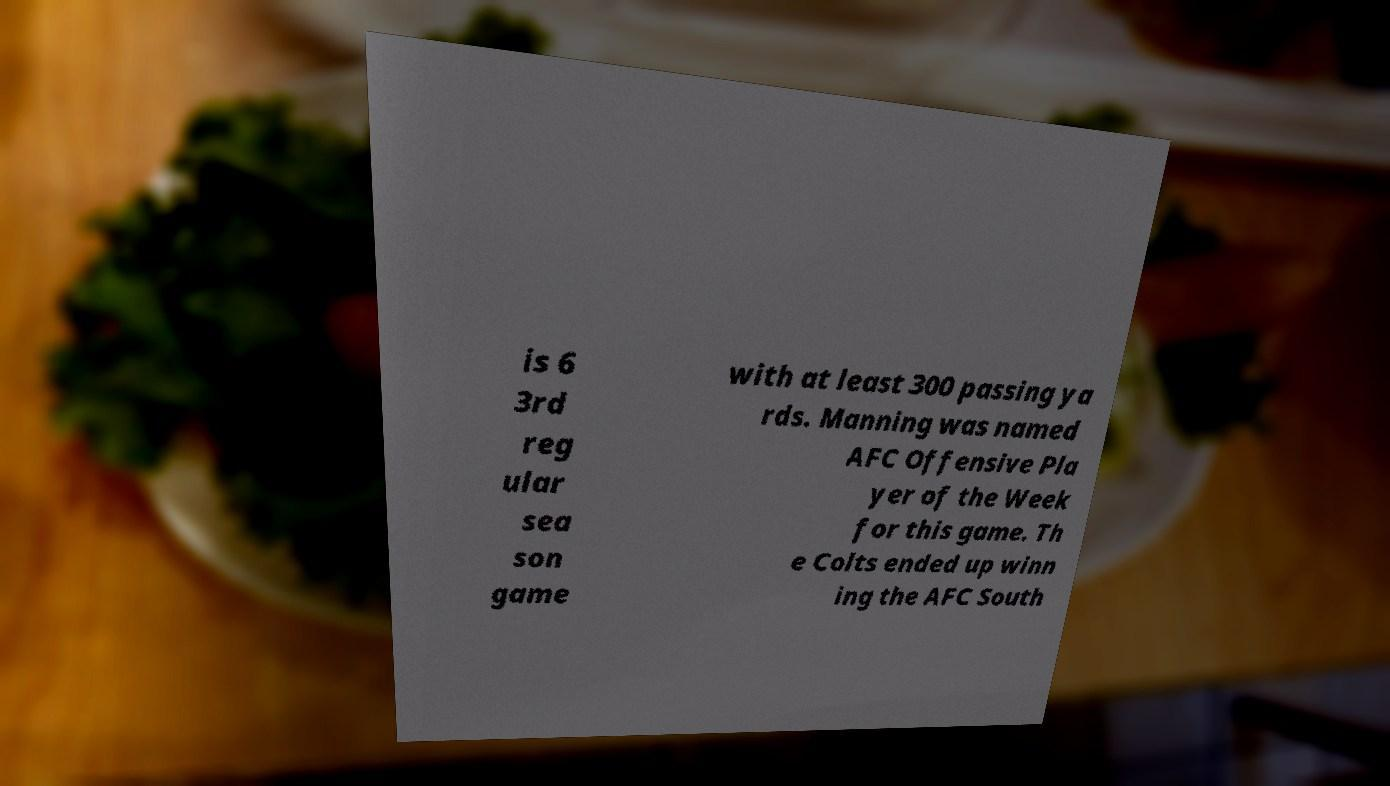Can you read and provide the text displayed in the image?This photo seems to have some interesting text. Can you extract and type it out for me? is 6 3rd reg ular sea son game with at least 300 passing ya rds. Manning was named AFC Offensive Pla yer of the Week for this game. Th e Colts ended up winn ing the AFC South 